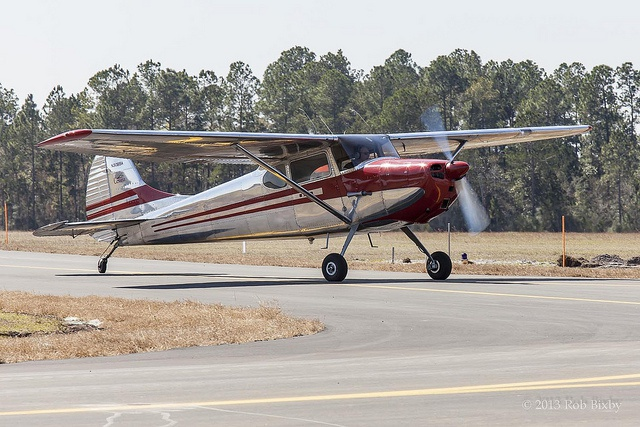Describe the objects in this image and their specific colors. I can see airplane in white, gray, darkgray, black, and maroon tones and people in white, black, and gray tones in this image. 